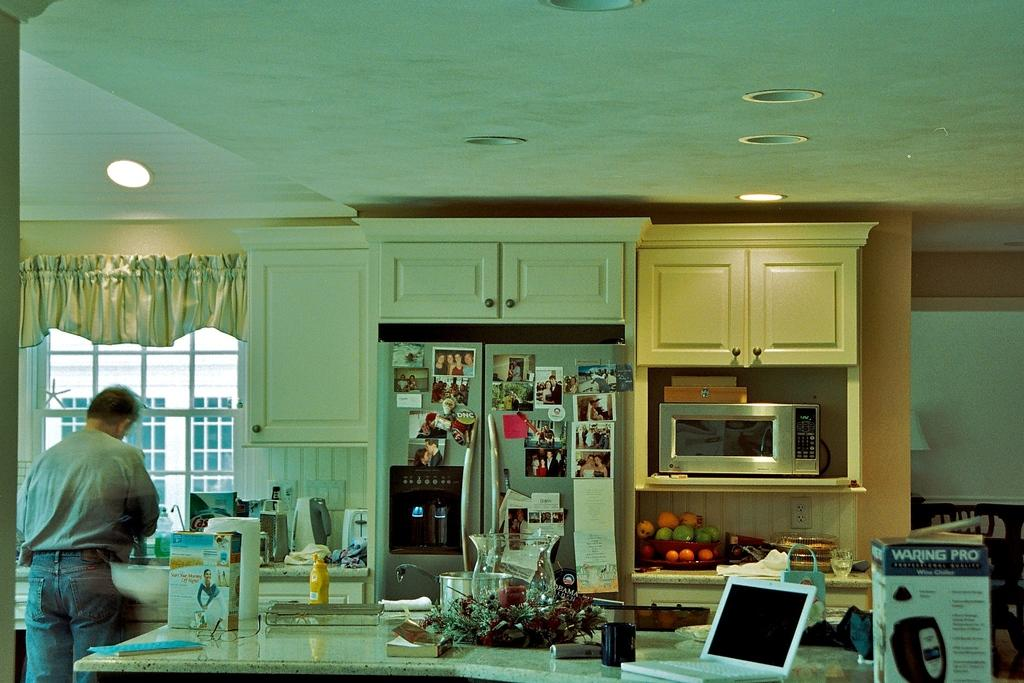<image>
Offer a succinct explanation of the picture presented. A man in a kitchen with a Waring Pro box on the table. 